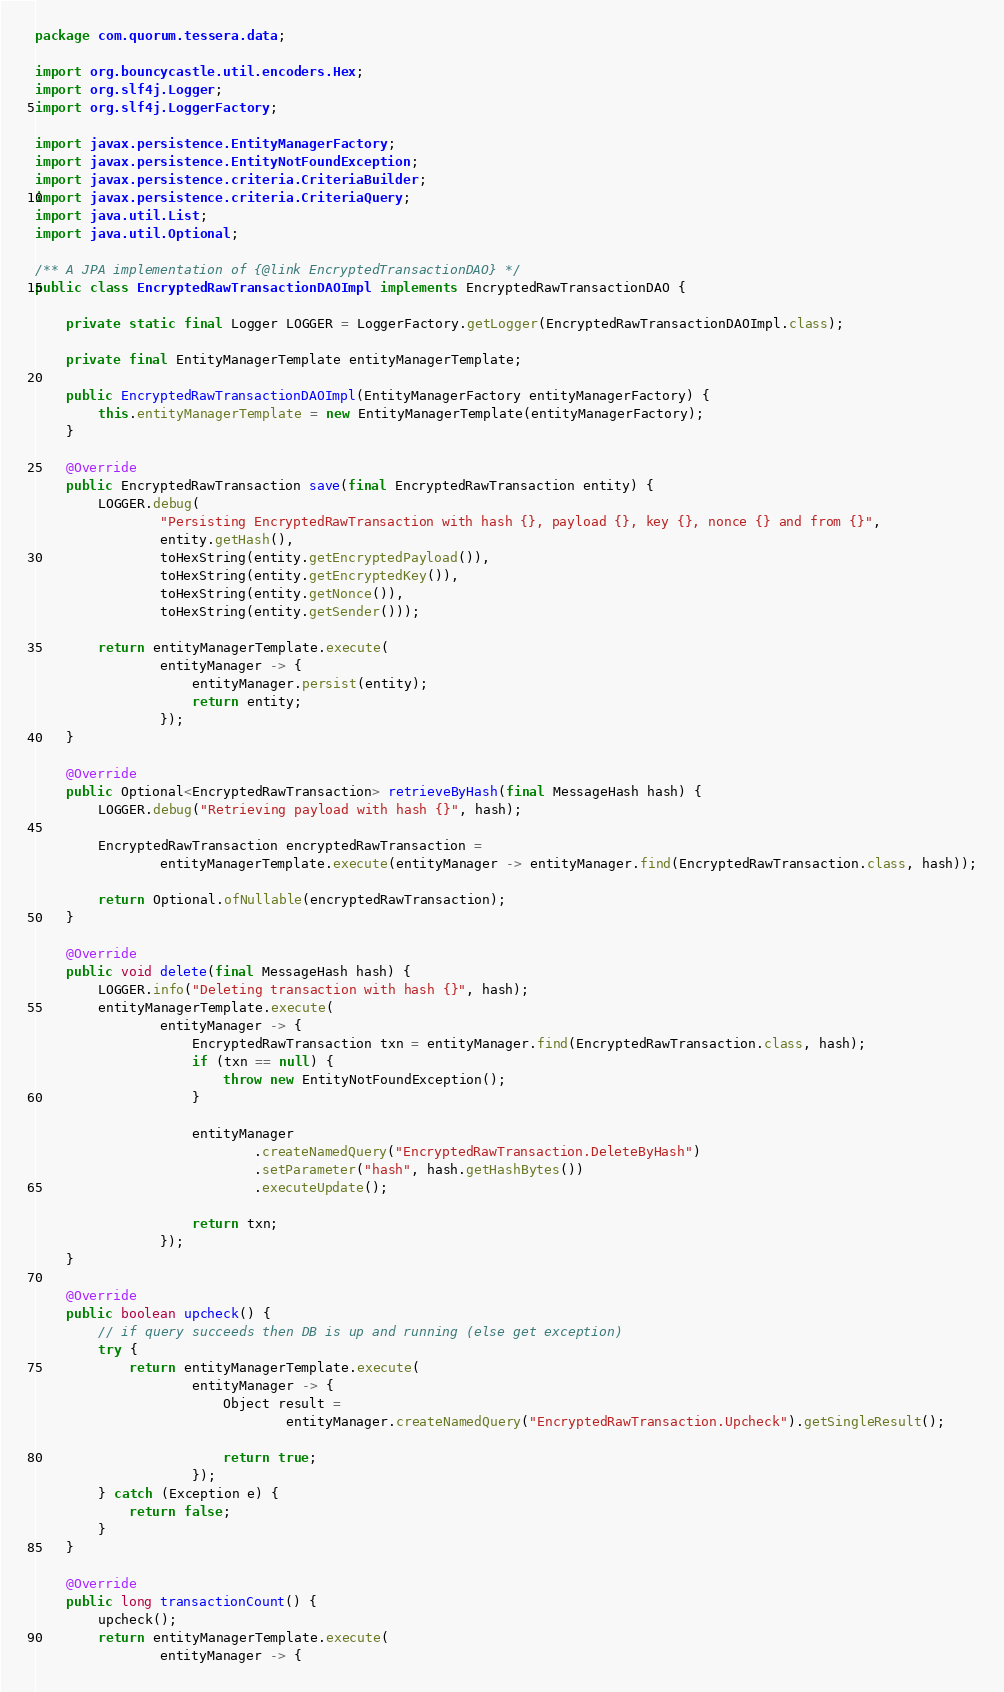Convert code to text. <code><loc_0><loc_0><loc_500><loc_500><_Java_>package com.quorum.tessera.data;

import org.bouncycastle.util.encoders.Hex;
import org.slf4j.Logger;
import org.slf4j.LoggerFactory;

import javax.persistence.EntityManagerFactory;
import javax.persistence.EntityNotFoundException;
import javax.persistence.criteria.CriteriaBuilder;
import javax.persistence.criteria.CriteriaQuery;
import java.util.List;
import java.util.Optional;

/** A JPA implementation of {@link EncryptedTransactionDAO} */
public class EncryptedRawTransactionDAOImpl implements EncryptedRawTransactionDAO {

    private static final Logger LOGGER = LoggerFactory.getLogger(EncryptedRawTransactionDAOImpl.class);

    private final EntityManagerTemplate entityManagerTemplate;

    public EncryptedRawTransactionDAOImpl(EntityManagerFactory entityManagerFactory) {
        this.entityManagerTemplate = new EntityManagerTemplate(entityManagerFactory);
    }

    @Override
    public EncryptedRawTransaction save(final EncryptedRawTransaction entity) {
        LOGGER.debug(
                "Persisting EncryptedRawTransaction with hash {}, payload {}, key {}, nonce {} and from {}",
                entity.getHash(),
                toHexString(entity.getEncryptedPayload()),
                toHexString(entity.getEncryptedKey()),
                toHexString(entity.getNonce()),
                toHexString(entity.getSender()));

        return entityManagerTemplate.execute(
                entityManager -> {
                    entityManager.persist(entity);
                    return entity;
                });
    }

    @Override
    public Optional<EncryptedRawTransaction> retrieveByHash(final MessageHash hash) {
        LOGGER.debug("Retrieving payload with hash {}", hash);

        EncryptedRawTransaction encryptedRawTransaction =
                entityManagerTemplate.execute(entityManager -> entityManager.find(EncryptedRawTransaction.class, hash));

        return Optional.ofNullable(encryptedRawTransaction);
    }

    @Override
    public void delete(final MessageHash hash) {
        LOGGER.info("Deleting transaction with hash {}", hash);
        entityManagerTemplate.execute(
                entityManager -> {
                    EncryptedRawTransaction txn = entityManager.find(EncryptedRawTransaction.class, hash);
                    if (txn == null) {
                        throw new EntityNotFoundException();
                    }

                    entityManager
                            .createNamedQuery("EncryptedRawTransaction.DeleteByHash")
                            .setParameter("hash", hash.getHashBytes())
                            .executeUpdate();

                    return txn;
                });
    }

    @Override
    public boolean upcheck() {
        // if query succeeds then DB is up and running (else get exception)
        try {
            return entityManagerTemplate.execute(
                    entityManager -> {
                        Object result =
                                entityManager.createNamedQuery("EncryptedRawTransaction.Upcheck").getSingleResult();

                        return true;
                    });
        } catch (Exception e) {
            return false;
        }
    }

    @Override
    public long transactionCount() {
        upcheck();
        return entityManagerTemplate.execute(
                entityManager -> {</code> 